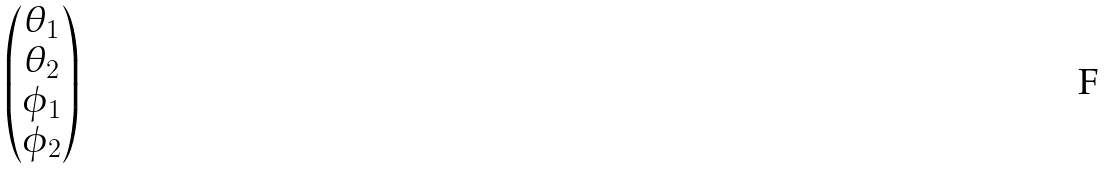Convert formula to latex. <formula><loc_0><loc_0><loc_500><loc_500>\begin{pmatrix} \theta _ { 1 } \\ \theta _ { 2 } \\ \phi _ { 1 } \\ \phi _ { 2 } \end{pmatrix}</formula> 